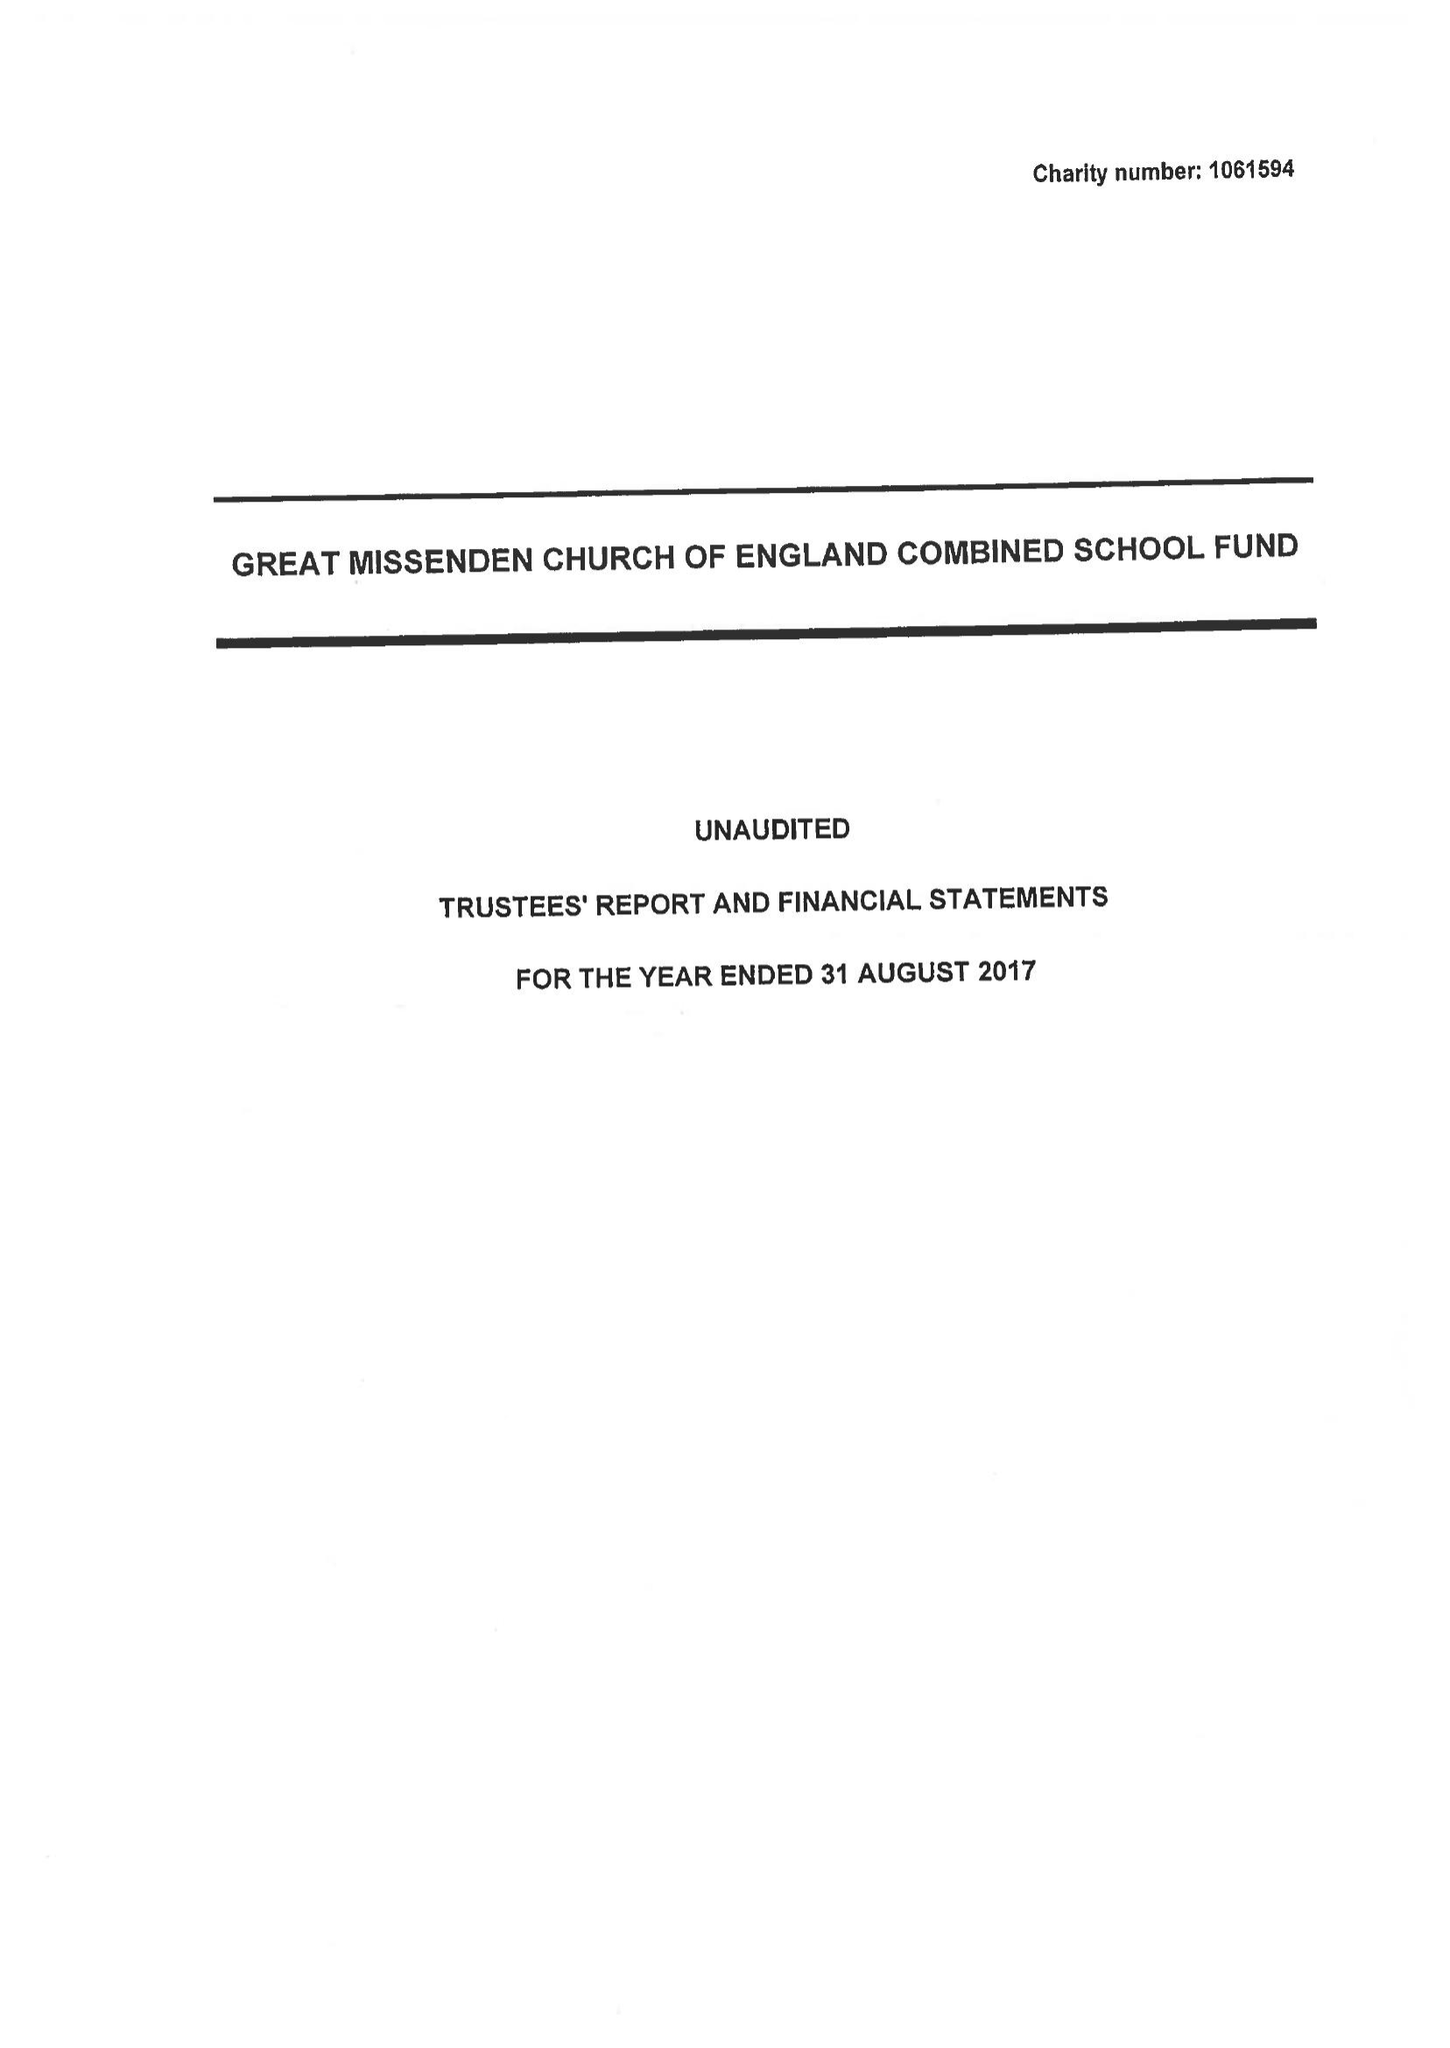What is the value for the address__post_town?
Answer the question using a single word or phrase. GREAT MISSENDEN 